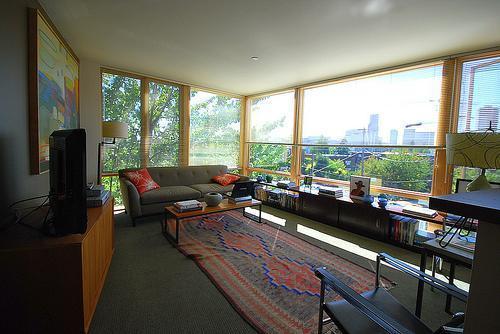How many lamps are in this room?
Give a very brief answer. 2. How many pillows are on the couch?
Give a very brief answer. 2. 